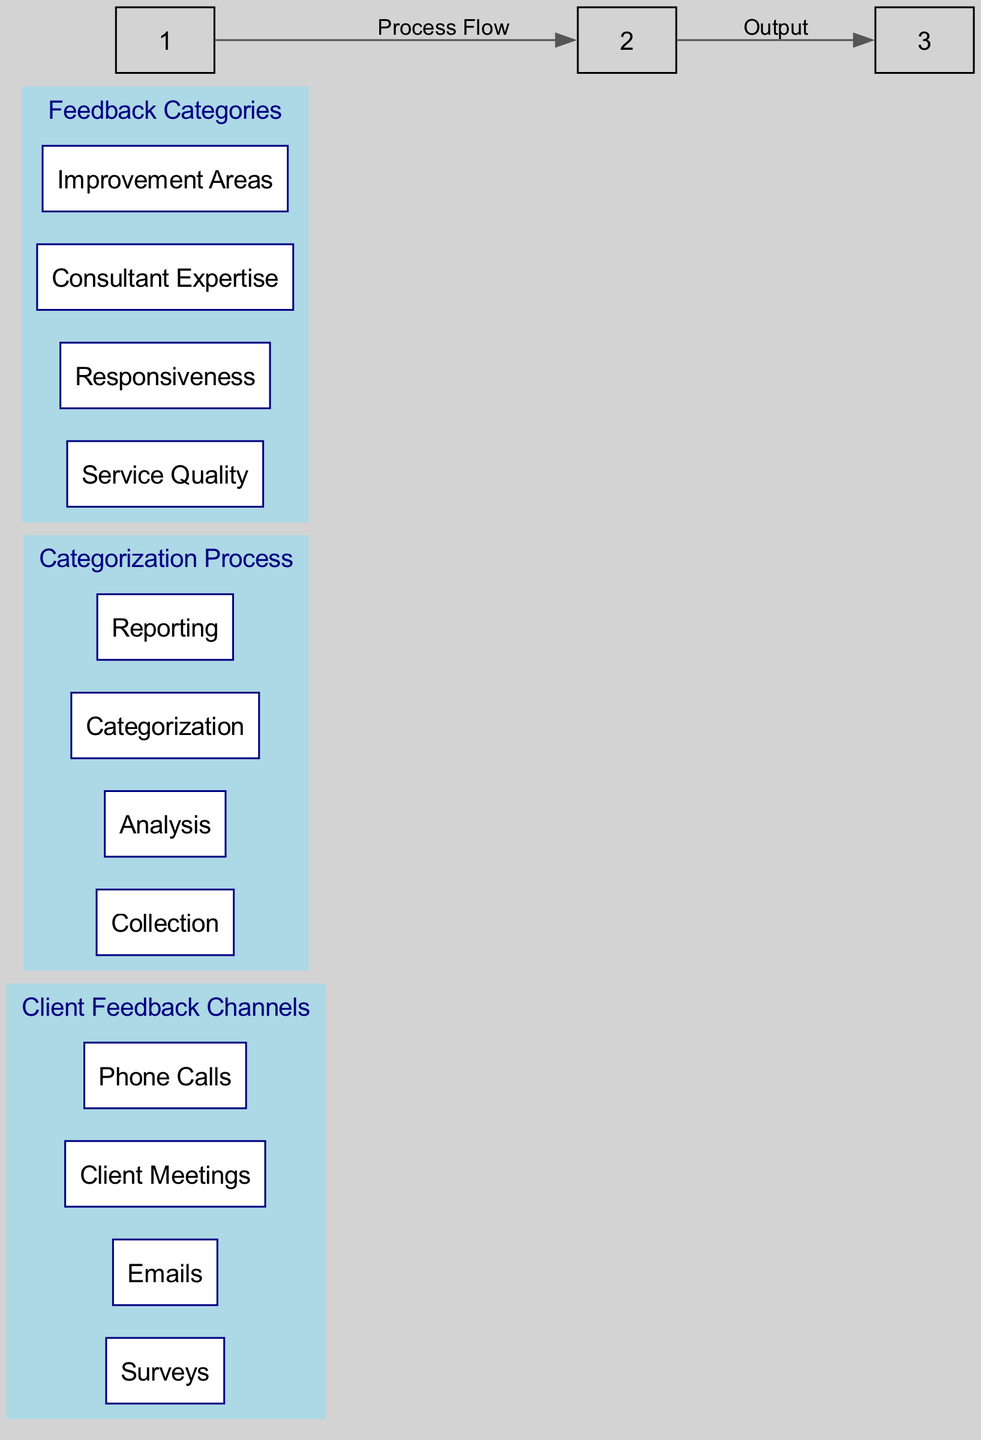What are the feedback collection channels? The diagram lists four channels under "Client Feedback Channels": Surveys, Emails, Client Meetings, and Phone Calls. These are specifically enumerated in the first cluster of the diagram.
Answer: Surveys, Emails, Client Meetings, Phone Calls How many steps are in the categorization process? The categorization process consists of four steps: Collection, Analysis, Categorization, and Reporting. These steps are shown in the second cluster of the diagram indicating the flow of how feedback is categorized.
Answer: Four What type of feedback is focused on timeliness? The feedback categorized under Responsiveness pertains to the timely response to client inquiries. This category is explicitly mentioned in the third cluster focusing on feedback categories.
Answer: Responsiveness How do the client feedback channels connect to the categorization process? The client feedback channels lead directly to the categorization process as depicted by the edge labeled "Process Flow" between the first and second clusters, establishing that feedback collected by various channels is processed in subsequent steps.
Answer: Process Flow Which feedback category addresses areas needing improvement? The category labeled Improvement Areas specifically addresses suggestions for areas in need of enhancement. This category is clearly listed under the Feedback Categories in the third cluster of the diagram.
Answer: Improvement Areas What is the first step in the feedback categorization process? The first step in the feedback categorization process is Collection, which involves gathering all feedback data as described in the second cluster under Categorization Process.
Answer: Collection How many main feedback categories are identified in the diagram? The diagram identifies four main feedback categories: Service Quality, Responsiveness, Consultant Expertise, and Improvement Areas. These are detailed in the third cluster indicating the classification of feedback.
Answer: Four Which aspect of feedback does the Expertise category focus on? The Expertise category focuses on feedback regarding the knowledge and skill level of the consultants, highlighting their expertise in the consulting services provided. This aspect is mentioned in the description of that particular category in the third cluster.
Answer: Consultant Expertise What connects the categorization process to the final output? The connection from the categorization process to the final output is represented by the edge labeled “Output” that links the second cluster to the third cluster, indicating that categorized feedback leads to the generation of reports.
Answer: Output 